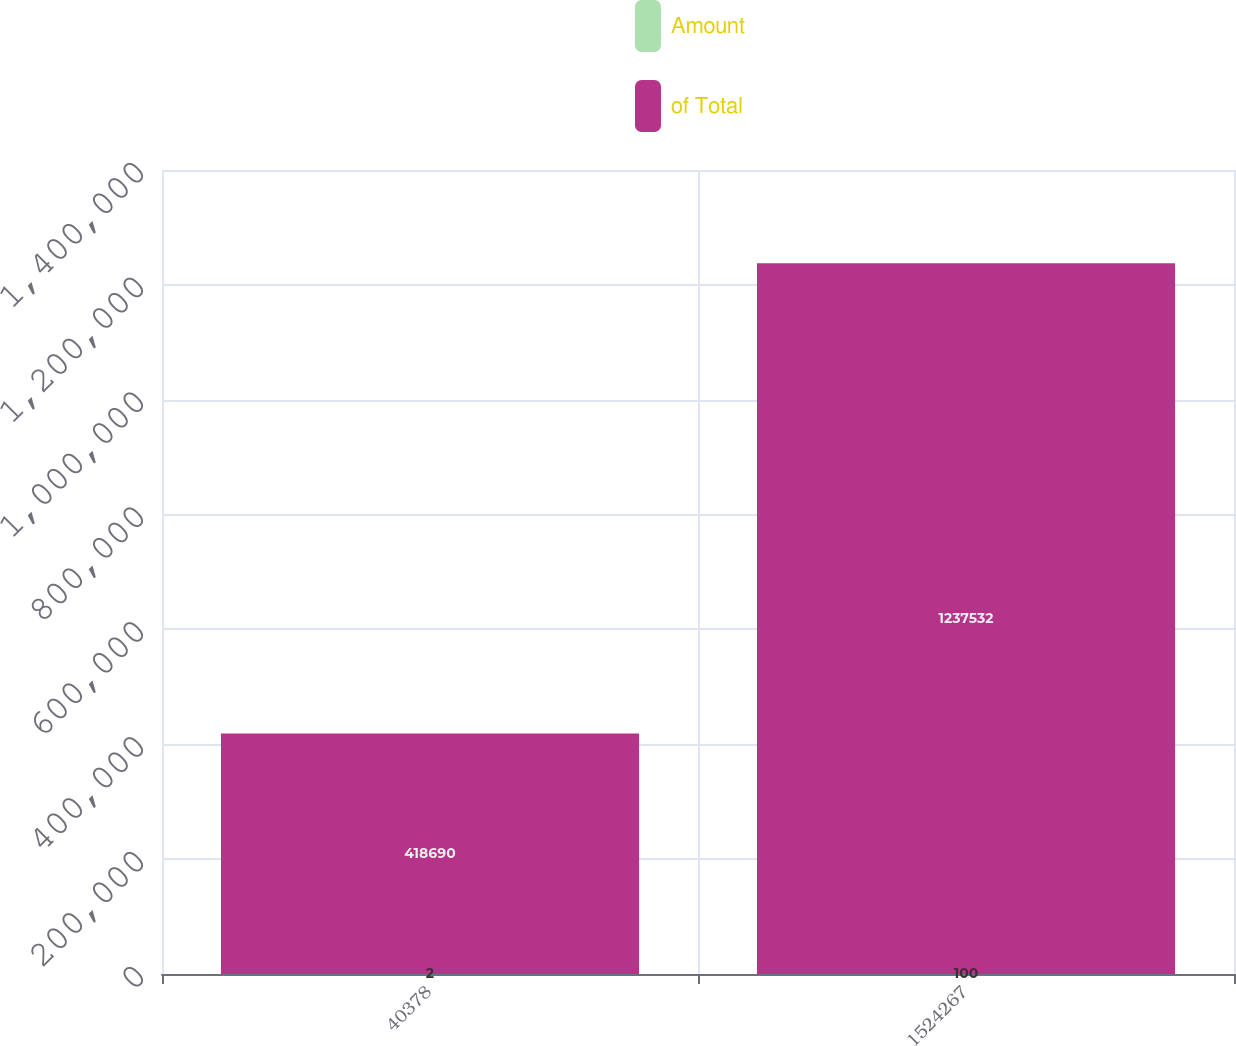Convert chart. <chart><loc_0><loc_0><loc_500><loc_500><stacked_bar_chart><ecel><fcel>40378<fcel>1524267<nl><fcel>Amount<fcel>2<fcel>100<nl><fcel>of Total<fcel>418690<fcel>1.23753e+06<nl></chart> 